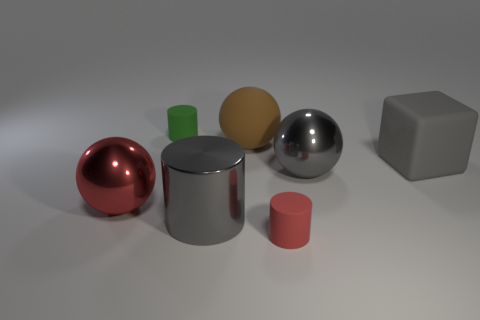What shape is the big matte thing that is the same color as the big cylinder?
Offer a terse response. Cube. What is the size of the rubber block that is the same color as the metallic cylinder?
Provide a succinct answer. Large. What number of purple objects are either cylinders or rubber cubes?
Provide a short and direct response. 0. Are there any large matte things that have the same color as the big cylinder?
Your response must be concise. Yes. Is there a red thing made of the same material as the large brown object?
Offer a very short reply. Yes. What shape is the thing that is both on the left side of the brown rubber sphere and behind the gray rubber object?
Offer a terse response. Cylinder. How many small things are either red balls or cubes?
Your answer should be very brief. 0. What is the gray block made of?
Your response must be concise. Rubber. What number of other things are the same shape as the large gray matte object?
Your response must be concise. 0. The matte cube is what size?
Keep it short and to the point. Large. 